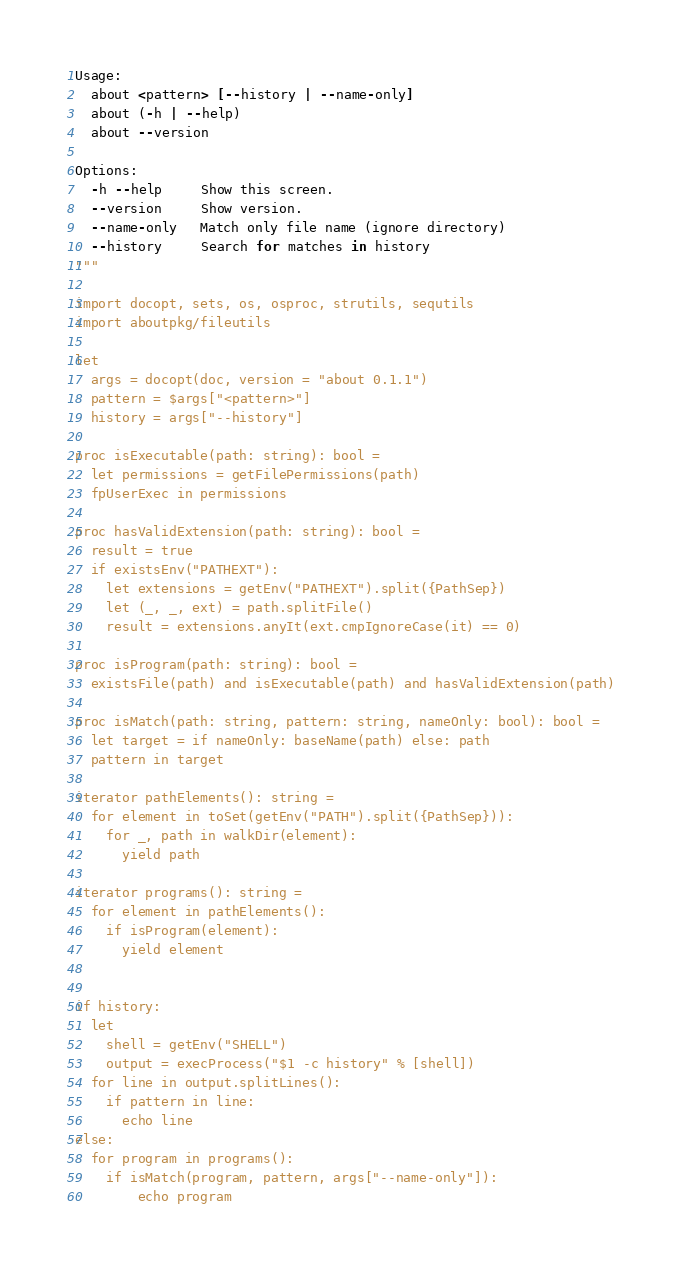<code> <loc_0><loc_0><loc_500><loc_500><_Nim_>
Usage:
  about <pattern> [--history | --name-only]
  about (-h | --help)
  about --version

Options:
  -h --help     Show this screen.
  --version     Show version.
  --name-only   Match only file name (ignore directory)
  --history     Search for matches in history
"""

import docopt, sets, os, osproc, strutils, sequtils
import aboutpkg/fileutils

let
  args = docopt(doc, version = "about 0.1.1")
  pattern = $args["<pattern>"]
  history = args["--history"]

proc isExecutable(path: string): bool =
  let permissions = getFilePermissions(path)
  fpUserExec in permissions

proc hasValidExtension(path: string): bool =
  result = true
  if existsEnv("PATHEXT"):
    let extensions = getEnv("PATHEXT").split({PathSep})
    let (_, _, ext) = path.splitFile()
    result = extensions.anyIt(ext.cmpIgnoreCase(it) == 0)

proc isProgram(path: string): bool =
  existsFile(path) and isExecutable(path) and hasValidExtension(path)

proc isMatch(path: string, pattern: string, nameOnly: bool): bool =
  let target = if nameOnly: baseName(path) else: path
  pattern in target

iterator pathElements(): string =
  for element in toSet(getEnv("PATH").split({PathSep})):
    for _, path in walkDir(element):
      yield path

iterator programs(): string =
  for element in pathElements():
    if isProgram(element):
      yield element


if history:
  let
    shell = getEnv("SHELL")
    output = execProcess("$1 -c history" % [shell])
  for line in output.splitLines():
    if pattern in line:
      echo line
else:
  for program in programs():
    if isMatch(program, pattern, args["--name-only"]):
        echo program
</code> 